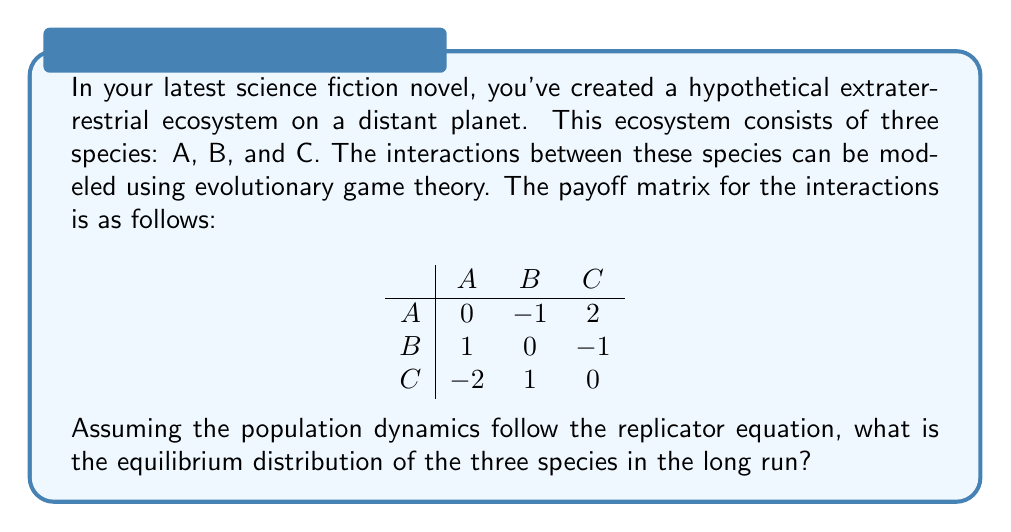Show me your answer to this math problem. To solve this problem, we need to use the concept of evolutionary stable strategies (ESS) and the replicator equation. Let's approach this step-by-step:

1) First, we need to set up the replicator equations for each species. Let $x$, $y$, and $z$ be the proportions of species A, B, and C respectively in the population. The replicator equations are:

   $$\frac{dx}{dt} = x(f_A - \bar{f})$$
   $$\frac{dy}{dt} = y(f_B - \bar{f})$$
   $$\frac{dz}{dt} = z(f_C - \bar{f})$$

   Where $f_A$, $f_B$, and $f_C$ are the fitness of each species, and $\bar{f}$ is the average fitness of the population.

2) The fitness of each species can be calculated from the payoff matrix:

   $$f_A = -y + 2z$$
   $$f_B = x - z$$
   $$f_C = -2x + y$$

3) The average fitness is:

   $$\bar{f} = xf_A + yf_B + zf_C = x(-y+2z) + y(x-z) + z(-2x+y)$$

4) At equilibrium, $\frac{dx}{dt} = \frac{dy}{dt} = \frac{dz}{dt} = 0$. This occurs when $f_A = f_B = f_C = \bar{f}$.

5) Solving these equations simultaneously:

   $$-y + 2z = x - z = -2x + y$$

6) Along with the constraint $x + y + z = 1$, we can solve for $x$, $y$, and $z$:

   $$x = y = z = \frac{1}{3}$$

This solution represents a mixed strategy equilibrium where each species occupies one-third of the population.

7) To verify if this is an ESS, we need to check if it's stable against invasions. The equilibrium is indeed stable because any deviation from this distribution will result in a lower fitness for the deviating species.
Answer: The equilibrium distribution of the three species in the long run is:

$$x = y = z = \frac{1}{3}$$

This means each species (A, B, and C) will occupy one-third of the population in the stable equilibrium state. 